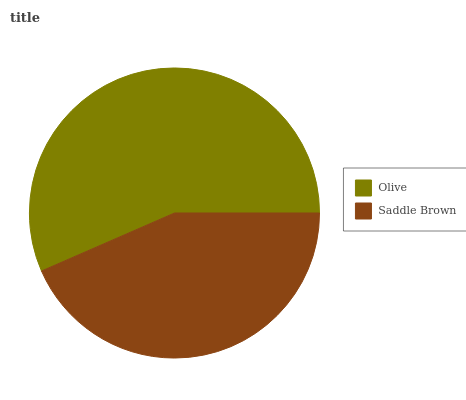Is Saddle Brown the minimum?
Answer yes or no. Yes. Is Olive the maximum?
Answer yes or no. Yes. Is Saddle Brown the maximum?
Answer yes or no. No. Is Olive greater than Saddle Brown?
Answer yes or no. Yes. Is Saddle Brown less than Olive?
Answer yes or no. Yes. Is Saddle Brown greater than Olive?
Answer yes or no. No. Is Olive less than Saddle Brown?
Answer yes or no. No. Is Olive the high median?
Answer yes or no. Yes. Is Saddle Brown the low median?
Answer yes or no. Yes. Is Saddle Brown the high median?
Answer yes or no. No. Is Olive the low median?
Answer yes or no. No. 